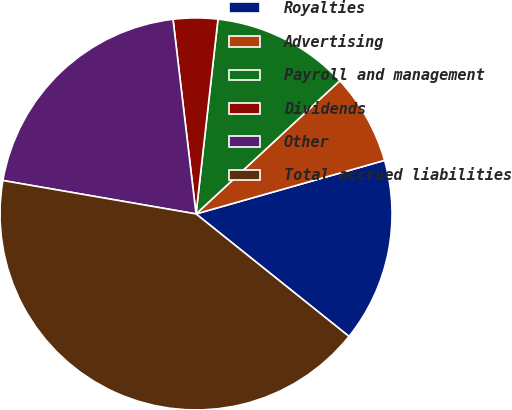<chart> <loc_0><loc_0><loc_500><loc_500><pie_chart><fcel>Royalties<fcel>Advertising<fcel>Payroll and management<fcel>Dividends<fcel>Other<fcel>Total accrued liabilities<nl><fcel>15.15%<fcel>7.49%<fcel>11.32%<fcel>3.66%<fcel>20.4%<fcel>41.98%<nl></chart> 